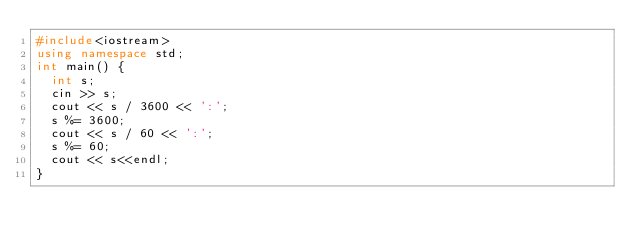Convert code to text. <code><loc_0><loc_0><loc_500><loc_500><_C++_>#include<iostream>
using namespace std;
int main() {
	int s;
	cin >> s;
	cout << s / 3600 << ':';
	s %= 3600;
	cout << s / 60 << ':';
	s %= 60;
	cout << s<<endl;
}
</code> 